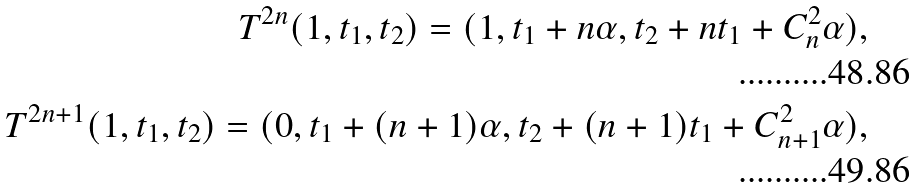Convert formula to latex. <formula><loc_0><loc_0><loc_500><loc_500>T ^ { 2 n } ( 1 , t _ { 1 } , t _ { 2 } ) = ( 1 , t _ { 1 } + n \alpha , t _ { 2 } + n t _ { 1 } + C _ { n } ^ { 2 } \alpha ) , \\ T ^ { 2 n + 1 } ( 1 , t _ { 1 } , t _ { 2 } ) = ( 0 , t _ { 1 } + ( n + 1 ) \alpha , t _ { 2 } + ( n + 1 ) t _ { 1 } + C _ { n + 1 } ^ { 2 } \alpha ) ,</formula> 